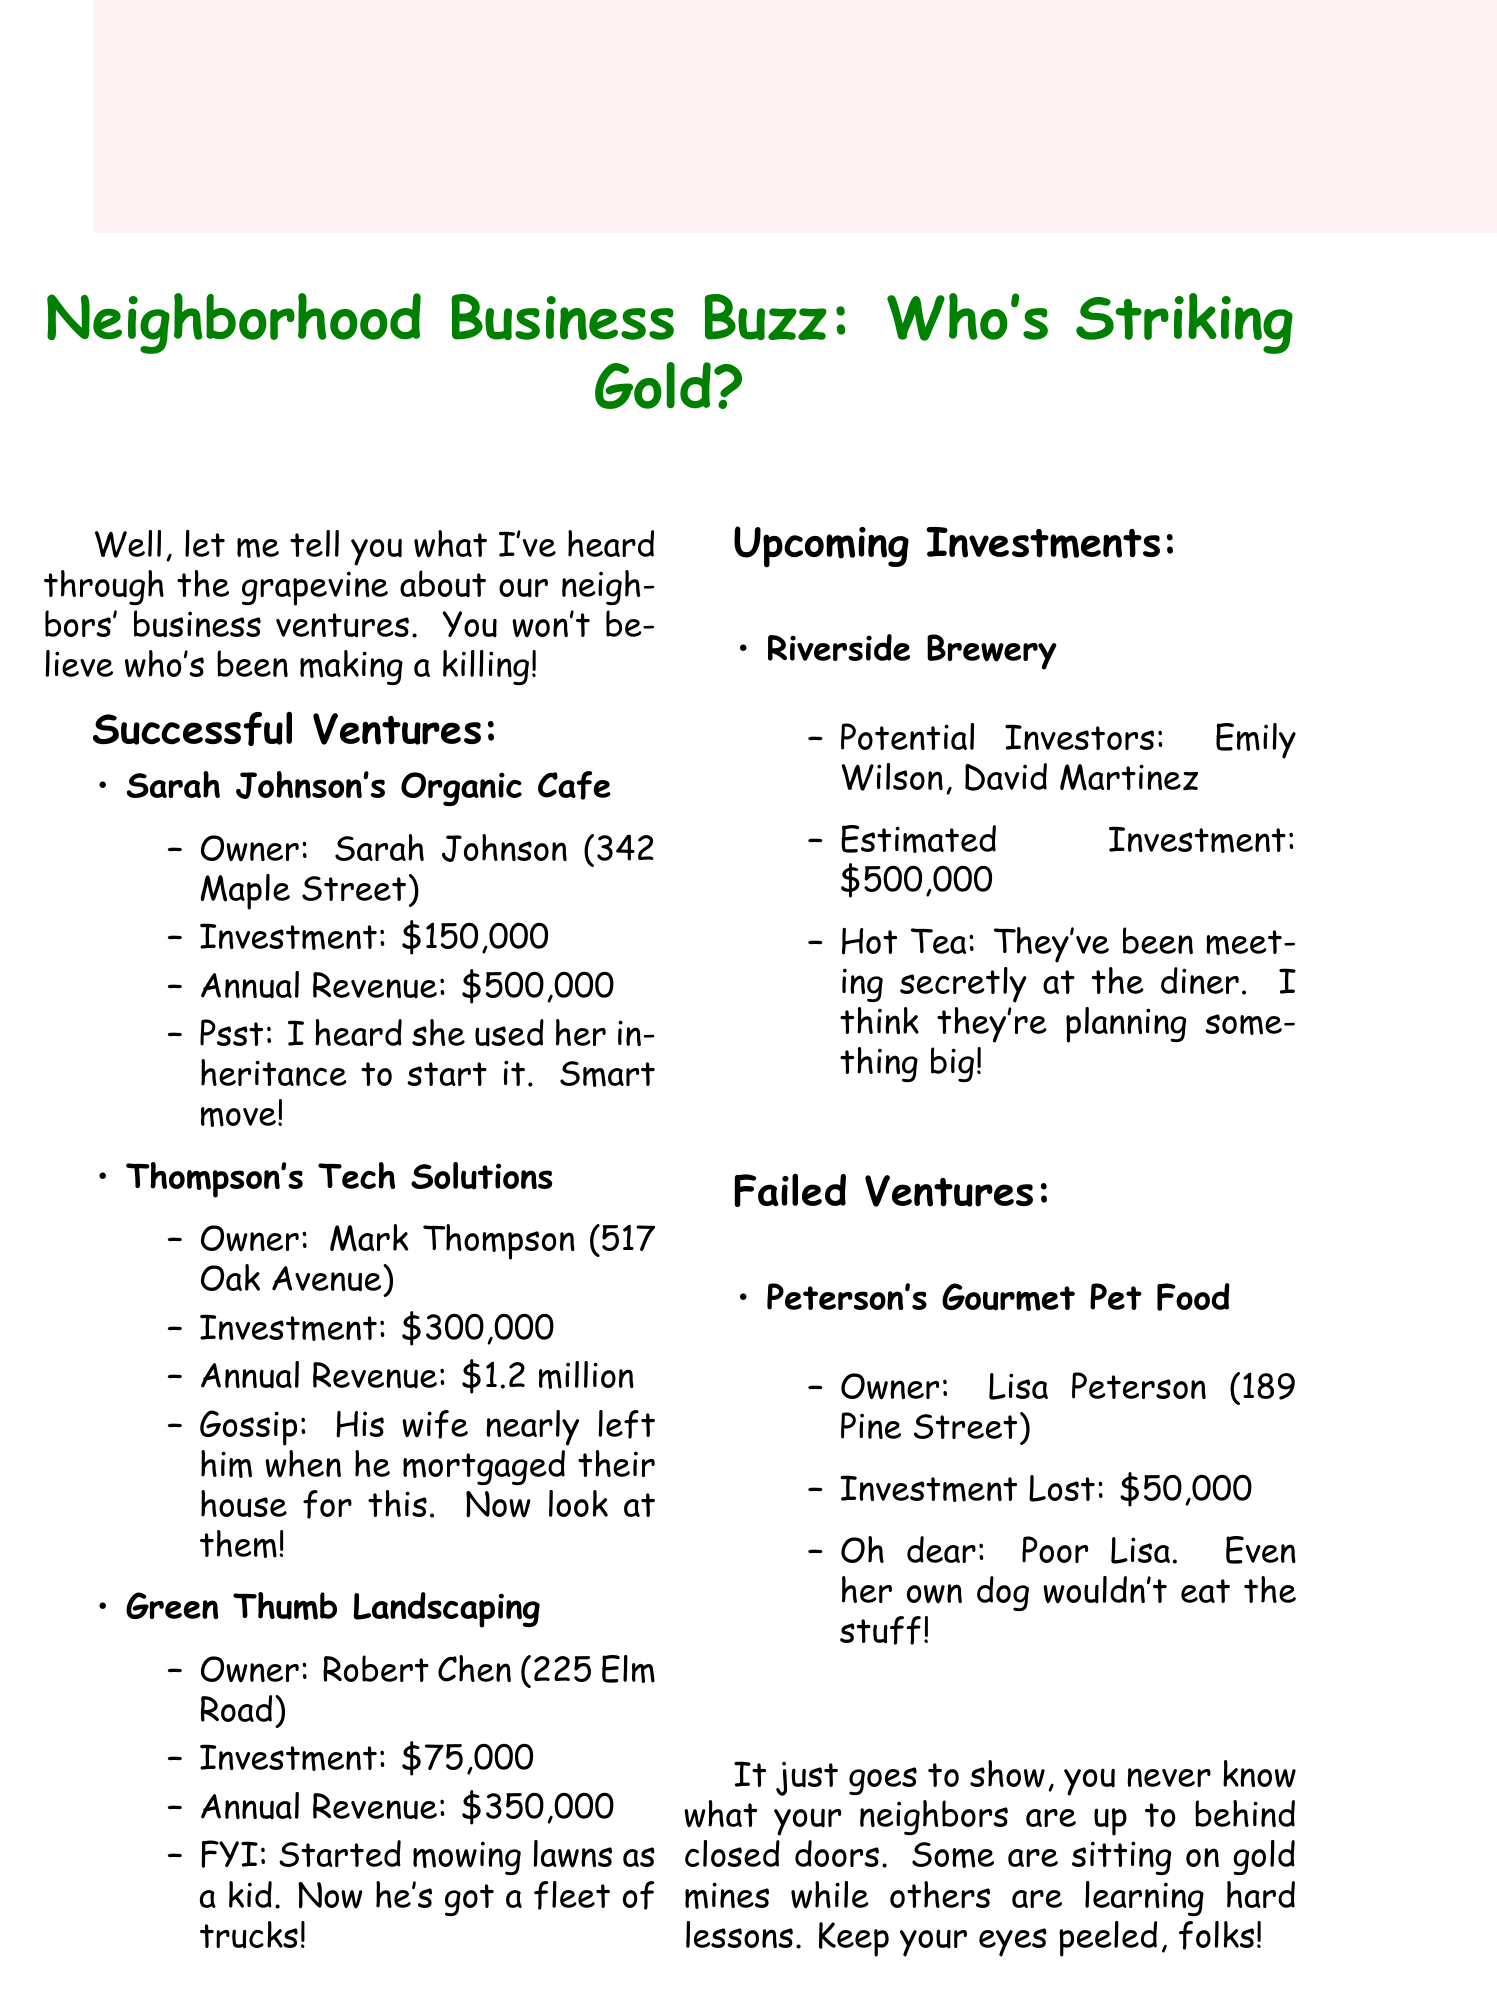What is the title of the report? The title of the report provides a snapshot of the content discussed, which is about neighborhood business investments.
Answer: Neighborhood Business Buzz: Who's Striking Gold? Who owns Sarah's Organic Cafe? This question addresses the specific ownership of the cafe mentioned in the report.
Answer: Sarah Johnson from 342 Maple Street How much did Mark Thompson invest in his tech company? This looks for the exact investment amount stated in the report for Thompson's Tech Solutions.
Answer: $300,000 What is the annual revenue of Green Thumb Landscaping? This retrieves the financial performance figure related to the landscaping business.
Answer: $350,000 Who are the potential investors for the Riverside Brewery? This question gathers information about who might be investing in the upcoming venture.
Answer: Emily Wilson, David Martinez How much money was lost in the failed venture? This identifies the specific investment loss related to Peterson's Gourmet Pet Food.
Answer: $50,000 Why is the gossip surrounding Lisa Peterson's venture negative? This requires reasoning to connect the investment loss with the gossip provided in the report.
Answer: Even her own dog wouldn't eat the stuff! What percentage increase in annual revenue did Sarah's cafe achieve over her investment? This combines data points to reason out the percentage change based on given amounts. Calculation: (500,000 - 150,000) / 150,000 * 100 = 233%.
Answer: 233% What lesson can be drawn from the document's conclusion? This question looks for a summarizing insight from the overall findings of the report.
Answer: Keep your eyes peeled, folks! 